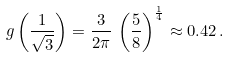<formula> <loc_0><loc_0><loc_500><loc_500>g \left ( \frac { 1 } { \sqrt { 3 } } \right ) = \frac { 3 } { 2 \pi } \, \left ( \frac { 5 } { 8 } \right ) ^ { \frac { 1 } { 4 } } \approx 0 . 4 2 \, .</formula> 